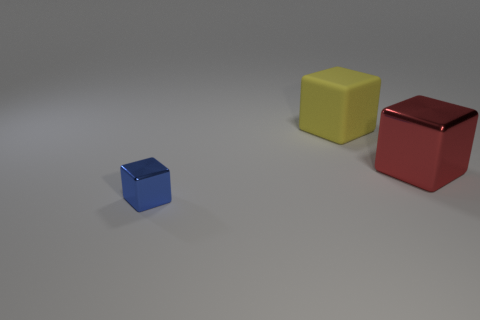Subtract all large cubes. How many cubes are left? 1 Add 3 red objects. How many objects exist? 6 Subtract all small spheres. Subtract all matte blocks. How many objects are left? 2 Add 2 matte blocks. How many matte blocks are left? 3 Add 2 red metal things. How many red metal things exist? 3 Subtract 0 gray spheres. How many objects are left? 3 